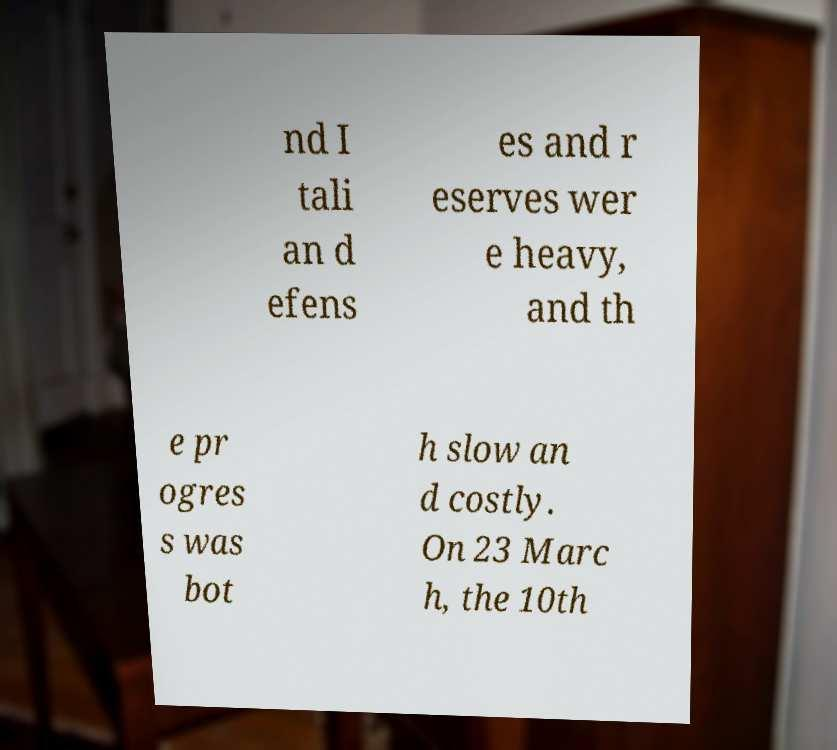Can you accurately transcribe the text from the provided image for me? nd I tali an d efens es and r eserves wer e heavy, and th e pr ogres s was bot h slow an d costly. On 23 Marc h, the 10th 